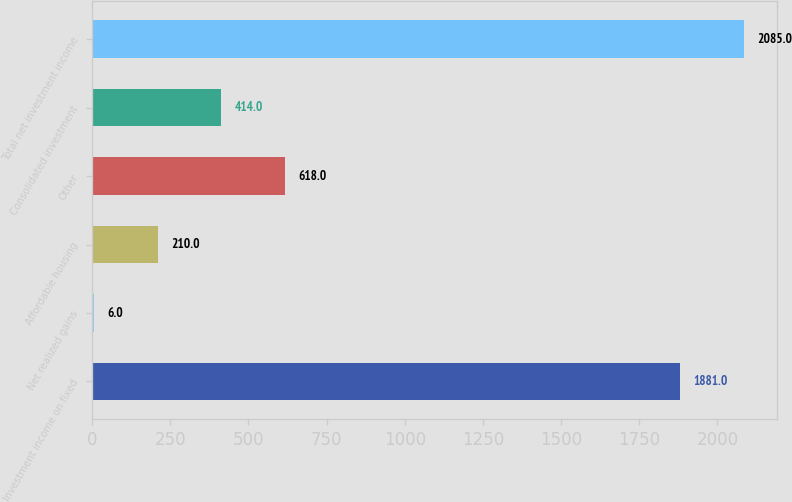<chart> <loc_0><loc_0><loc_500><loc_500><bar_chart><fcel>Investment income on fixed<fcel>Net realized gains<fcel>Affordable housing<fcel>Other<fcel>Consolidated investment<fcel>Total net investment income<nl><fcel>1881<fcel>6<fcel>210<fcel>618<fcel>414<fcel>2085<nl></chart> 